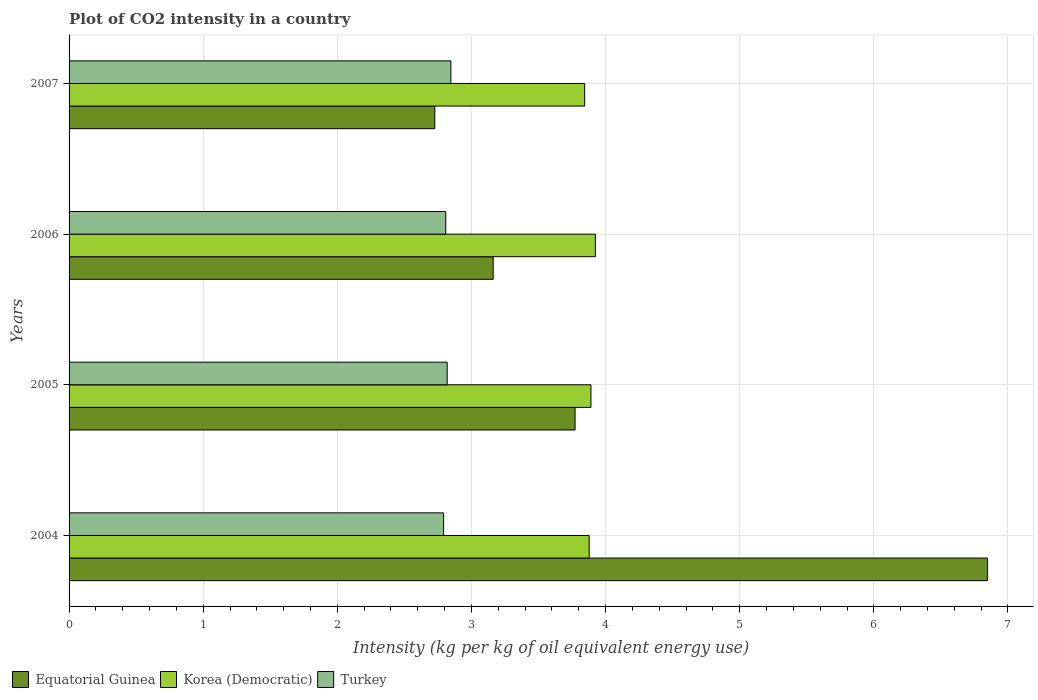How many groups of bars are there?
Offer a terse response. 4. Are the number of bars per tick equal to the number of legend labels?
Your response must be concise. Yes. How many bars are there on the 3rd tick from the top?
Your answer should be very brief. 3. What is the label of the 3rd group of bars from the top?
Your response must be concise. 2005. In how many cases, is the number of bars for a given year not equal to the number of legend labels?
Your response must be concise. 0. What is the CO2 intensity in in Equatorial Guinea in 2007?
Your answer should be compact. 2.73. Across all years, what is the maximum CO2 intensity in in Korea (Democratic)?
Offer a terse response. 3.92. Across all years, what is the minimum CO2 intensity in in Equatorial Guinea?
Provide a succinct answer. 2.73. What is the total CO2 intensity in in Korea (Democratic) in the graph?
Ensure brevity in your answer.  15.54. What is the difference between the CO2 intensity in in Turkey in 2006 and that in 2007?
Your answer should be compact. -0.04. What is the difference between the CO2 intensity in in Korea (Democratic) in 2004 and the CO2 intensity in in Equatorial Guinea in 2007?
Offer a very short reply. 1.15. What is the average CO2 intensity in in Equatorial Guinea per year?
Make the answer very short. 4.13. In the year 2007, what is the difference between the CO2 intensity in in Korea (Democratic) and CO2 intensity in in Turkey?
Offer a terse response. 1. In how many years, is the CO2 intensity in in Korea (Democratic) greater than 6.4 kg?
Your answer should be very brief. 0. What is the ratio of the CO2 intensity in in Korea (Democratic) in 2004 to that in 2007?
Keep it short and to the point. 1.01. Is the CO2 intensity in in Korea (Democratic) in 2004 less than that in 2007?
Provide a succinct answer. No. What is the difference between the highest and the second highest CO2 intensity in in Equatorial Guinea?
Make the answer very short. 3.08. What is the difference between the highest and the lowest CO2 intensity in in Korea (Democratic)?
Your response must be concise. 0.08. What does the 2nd bar from the top in 2007 represents?
Keep it short and to the point. Korea (Democratic). Is it the case that in every year, the sum of the CO2 intensity in in Turkey and CO2 intensity in in Korea (Democratic) is greater than the CO2 intensity in in Equatorial Guinea?
Keep it short and to the point. No. How many years are there in the graph?
Your response must be concise. 4. What is the difference between two consecutive major ticks on the X-axis?
Provide a succinct answer. 1. Are the values on the major ticks of X-axis written in scientific E-notation?
Offer a terse response. No. Does the graph contain any zero values?
Make the answer very short. No. Where does the legend appear in the graph?
Offer a very short reply. Bottom left. How many legend labels are there?
Your answer should be compact. 3. What is the title of the graph?
Give a very brief answer. Plot of CO2 intensity in a country. Does "Indonesia" appear as one of the legend labels in the graph?
Provide a short and direct response. No. What is the label or title of the X-axis?
Your response must be concise. Intensity (kg per kg of oil equivalent energy use). What is the Intensity (kg per kg of oil equivalent energy use) of Equatorial Guinea in 2004?
Offer a very short reply. 6.85. What is the Intensity (kg per kg of oil equivalent energy use) of Korea (Democratic) in 2004?
Ensure brevity in your answer.  3.88. What is the Intensity (kg per kg of oil equivalent energy use) in Turkey in 2004?
Give a very brief answer. 2.79. What is the Intensity (kg per kg of oil equivalent energy use) of Equatorial Guinea in 2005?
Provide a short and direct response. 3.77. What is the Intensity (kg per kg of oil equivalent energy use) of Korea (Democratic) in 2005?
Offer a terse response. 3.89. What is the Intensity (kg per kg of oil equivalent energy use) in Turkey in 2005?
Your response must be concise. 2.82. What is the Intensity (kg per kg of oil equivalent energy use) in Equatorial Guinea in 2006?
Offer a very short reply. 3.16. What is the Intensity (kg per kg of oil equivalent energy use) in Korea (Democratic) in 2006?
Give a very brief answer. 3.92. What is the Intensity (kg per kg of oil equivalent energy use) of Turkey in 2006?
Offer a terse response. 2.81. What is the Intensity (kg per kg of oil equivalent energy use) in Equatorial Guinea in 2007?
Offer a terse response. 2.73. What is the Intensity (kg per kg of oil equivalent energy use) of Korea (Democratic) in 2007?
Make the answer very short. 3.84. What is the Intensity (kg per kg of oil equivalent energy use) of Turkey in 2007?
Provide a succinct answer. 2.85. Across all years, what is the maximum Intensity (kg per kg of oil equivalent energy use) in Equatorial Guinea?
Keep it short and to the point. 6.85. Across all years, what is the maximum Intensity (kg per kg of oil equivalent energy use) of Korea (Democratic)?
Offer a terse response. 3.92. Across all years, what is the maximum Intensity (kg per kg of oil equivalent energy use) of Turkey?
Your answer should be compact. 2.85. Across all years, what is the minimum Intensity (kg per kg of oil equivalent energy use) in Equatorial Guinea?
Provide a succinct answer. 2.73. Across all years, what is the minimum Intensity (kg per kg of oil equivalent energy use) of Korea (Democratic)?
Offer a terse response. 3.84. Across all years, what is the minimum Intensity (kg per kg of oil equivalent energy use) in Turkey?
Provide a succinct answer. 2.79. What is the total Intensity (kg per kg of oil equivalent energy use) in Equatorial Guinea in the graph?
Ensure brevity in your answer.  16.51. What is the total Intensity (kg per kg of oil equivalent energy use) of Korea (Democratic) in the graph?
Ensure brevity in your answer.  15.54. What is the total Intensity (kg per kg of oil equivalent energy use) of Turkey in the graph?
Provide a short and direct response. 11.27. What is the difference between the Intensity (kg per kg of oil equivalent energy use) of Equatorial Guinea in 2004 and that in 2005?
Keep it short and to the point. 3.08. What is the difference between the Intensity (kg per kg of oil equivalent energy use) in Korea (Democratic) in 2004 and that in 2005?
Your answer should be compact. -0.01. What is the difference between the Intensity (kg per kg of oil equivalent energy use) in Turkey in 2004 and that in 2005?
Keep it short and to the point. -0.03. What is the difference between the Intensity (kg per kg of oil equivalent energy use) in Equatorial Guinea in 2004 and that in 2006?
Give a very brief answer. 3.69. What is the difference between the Intensity (kg per kg of oil equivalent energy use) in Korea (Democratic) in 2004 and that in 2006?
Make the answer very short. -0.05. What is the difference between the Intensity (kg per kg of oil equivalent energy use) of Turkey in 2004 and that in 2006?
Offer a terse response. -0.02. What is the difference between the Intensity (kg per kg of oil equivalent energy use) in Equatorial Guinea in 2004 and that in 2007?
Your answer should be compact. 4.12. What is the difference between the Intensity (kg per kg of oil equivalent energy use) of Korea (Democratic) in 2004 and that in 2007?
Provide a succinct answer. 0.03. What is the difference between the Intensity (kg per kg of oil equivalent energy use) of Turkey in 2004 and that in 2007?
Provide a short and direct response. -0.05. What is the difference between the Intensity (kg per kg of oil equivalent energy use) in Equatorial Guinea in 2005 and that in 2006?
Your answer should be compact. 0.61. What is the difference between the Intensity (kg per kg of oil equivalent energy use) of Korea (Democratic) in 2005 and that in 2006?
Offer a very short reply. -0.03. What is the difference between the Intensity (kg per kg of oil equivalent energy use) of Turkey in 2005 and that in 2006?
Keep it short and to the point. 0.01. What is the difference between the Intensity (kg per kg of oil equivalent energy use) of Equatorial Guinea in 2005 and that in 2007?
Your answer should be compact. 1.05. What is the difference between the Intensity (kg per kg of oil equivalent energy use) in Korea (Democratic) in 2005 and that in 2007?
Your answer should be very brief. 0.05. What is the difference between the Intensity (kg per kg of oil equivalent energy use) in Turkey in 2005 and that in 2007?
Provide a succinct answer. -0.03. What is the difference between the Intensity (kg per kg of oil equivalent energy use) of Equatorial Guinea in 2006 and that in 2007?
Ensure brevity in your answer.  0.44. What is the difference between the Intensity (kg per kg of oil equivalent energy use) in Korea (Democratic) in 2006 and that in 2007?
Your response must be concise. 0.08. What is the difference between the Intensity (kg per kg of oil equivalent energy use) in Turkey in 2006 and that in 2007?
Your response must be concise. -0.04. What is the difference between the Intensity (kg per kg of oil equivalent energy use) of Equatorial Guinea in 2004 and the Intensity (kg per kg of oil equivalent energy use) of Korea (Democratic) in 2005?
Make the answer very short. 2.96. What is the difference between the Intensity (kg per kg of oil equivalent energy use) in Equatorial Guinea in 2004 and the Intensity (kg per kg of oil equivalent energy use) in Turkey in 2005?
Keep it short and to the point. 4.03. What is the difference between the Intensity (kg per kg of oil equivalent energy use) of Korea (Democratic) in 2004 and the Intensity (kg per kg of oil equivalent energy use) of Turkey in 2005?
Your response must be concise. 1.06. What is the difference between the Intensity (kg per kg of oil equivalent energy use) of Equatorial Guinea in 2004 and the Intensity (kg per kg of oil equivalent energy use) of Korea (Democratic) in 2006?
Ensure brevity in your answer.  2.92. What is the difference between the Intensity (kg per kg of oil equivalent energy use) in Equatorial Guinea in 2004 and the Intensity (kg per kg of oil equivalent energy use) in Turkey in 2006?
Ensure brevity in your answer.  4.04. What is the difference between the Intensity (kg per kg of oil equivalent energy use) of Korea (Democratic) in 2004 and the Intensity (kg per kg of oil equivalent energy use) of Turkey in 2006?
Offer a very short reply. 1.07. What is the difference between the Intensity (kg per kg of oil equivalent energy use) of Equatorial Guinea in 2004 and the Intensity (kg per kg of oil equivalent energy use) of Korea (Democratic) in 2007?
Your answer should be very brief. 3. What is the difference between the Intensity (kg per kg of oil equivalent energy use) in Equatorial Guinea in 2004 and the Intensity (kg per kg of oil equivalent energy use) in Turkey in 2007?
Offer a terse response. 4. What is the difference between the Intensity (kg per kg of oil equivalent energy use) in Korea (Democratic) in 2004 and the Intensity (kg per kg of oil equivalent energy use) in Turkey in 2007?
Your response must be concise. 1.03. What is the difference between the Intensity (kg per kg of oil equivalent energy use) of Equatorial Guinea in 2005 and the Intensity (kg per kg of oil equivalent energy use) of Korea (Democratic) in 2006?
Your response must be concise. -0.15. What is the difference between the Intensity (kg per kg of oil equivalent energy use) of Equatorial Guinea in 2005 and the Intensity (kg per kg of oil equivalent energy use) of Turkey in 2006?
Ensure brevity in your answer.  0.96. What is the difference between the Intensity (kg per kg of oil equivalent energy use) of Korea (Democratic) in 2005 and the Intensity (kg per kg of oil equivalent energy use) of Turkey in 2006?
Keep it short and to the point. 1.08. What is the difference between the Intensity (kg per kg of oil equivalent energy use) of Equatorial Guinea in 2005 and the Intensity (kg per kg of oil equivalent energy use) of Korea (Democratic) in 2007?
Make the answer very short. -0.07. What is the difference between the Intensity (kg per kg of oil equivalent energy use) of Equatorial Guinea in 2005 and the Intensity (kg per kg of oil equivalent energy use) of Turkey in 2007?
Your answer should be very brief. 0.93. What is the difference between the Intensity (kg per kg of oil equivalent energy use) of Korea (Democratic) in 2005 and the Intensity (kg per kg of oil equivalent energy use) of Turkey in 2007?
Your answer should be very brief. 1.04. What is the difference between the Intensity (kg per kg of oil equivalent energy use) in Equatorial Guinea in 2006 and the Intensity (kg per kg of oil equivalent energy use) in Korea (Democratic) in 2007?
Make the answer very short. -0.68. What is the difference between the Intensity (kg per kg of oil equivalent energy use) in Equatorial Guinea in 2006 and the Intensity (kg per kg of oil equivalent energy use) in Turkey in 2007?
Offer a very short reply. 0.32. What is the difference between the Intensity (kg per kg of oil equivalent energy use) in Korea (Democratic) in 2006 and the Intensity (kg per kg of oil equivalent energy use) in Turkey in 2007?
Your response must be concise. 1.08. What is the average Intensity (kg per kg of oil equivalent energy use) in Equatorial Guinea per year?
Your answer should be compact. 4.13. What is the average Intensity (kg per kg of oil equivalent energy use) in Korea (Democratic) per year?
Your answer should be very brief. 3.88. What is the average Intensity (kg per kg of oil equivalent energy use) in Turkey per year?
Offer a very short reply. 2.82. In the year 2004, what is the difference between the Intensity (kg per kg of oil equivalent energy use) in Equatorial Guinea and Intensity (kg per kg of oil equivalent energy use) in Korea (Democratic)?
Offer a terse response. 2.97. In the year 2004, what is the difference between the Intensity (kg per kg of oil equivalent energy use) in Equatorial Guinea and Intensity (kg per kg of oil equivalent energy use) in Turkey?
Provide a short and direct response. 4.06. In the year 2004, what is the difference between the Intensity (kg per kg of oil equivalent energy use) in Korea (Democratic) and Intensity (kg per kg of oil equivalent energy use) in Turkey?
Provide a succinct answer. 1.09. In the year 2005, what is the difference between the Intensity (kg per kg of oil equivalent energy use) of Equatorial Guinea and Intensity (kg per kg of oil equivalent energy use) of Korea (Democratic)?
Keep it short and to the point. -0.12. In the year 2005, what is the difference between the Intensity (kg per kg of oil equivalent energy use) in Equatorial Guinea and Intensity (kg per kg of oil equivalent energy use) in Turkey?
Your answer should be very brief. 0.95. In the year 2005, what is the difference between the Intensity (kg per kg of oil equivalent energy use) in Korea (Democratic) and Intensity (kg per kg of oil equivalent energy use) in Turkey?
Ensure brevity in your answer.  1.07. In the year 2006, what is the difference between the Intensity (kg per kg of oil equivalent energy use) of Equatorial Guinea and Intensity (kg per kg of oil equivalent energy use) of Korea (Democratic)?
Make the answer very short. -0.76. In the year 2006, what is the difference between the Intensity (kg per kg of oil equivalent energy use) in Equatorial Guinea and Intensity (kg per kg of oil equivalent energy use) in Turkey?
Give a very brief answer. 0.35. In the year 2006, what is the difference between the Intensity (kg per kg of oil equivalent energy use) of Korea (Democratic) and Intensity (kg per kg of oil equivalent energy use) of Turkey?
Ensure brevity in your answer.  1.12. In the year 2007, what is the difference between the Intensity (kg per kg of oil equivalent energy use) of Equatorial Guinea and Intensity (kg per kg of oil equivalent energy use) of Korea (Democratic)?
Give a very brief answer. -1.12. In the year 2007, what is the difference between the Intensity (kg per kg of oil equivalent energy use) in Equatorial Guinea and Intensity (kg per kg of oil equivalent energy use) in Turkey?
Your answer should be very brief. -0.12. What is the ratio of the Intensity (kg per kg of oil equivalent energy use) in Equatorial Guinea in 2004 to that in 2005?
Keep it short and to the point. 1.82. What is the ratio of the Intensity (kg per kg of oil equivalent energy use) of Turkey in 2004 to that in 2005?
Provide a succinct answer. 0.99. What is the ratio of the Intensity (kg per kg of oil equivalent energy use) in Equatorial Guinea in 2004 to that in 2006?
Give a very brief answer. 2.17. What is the ratio of the Intensity (kg per kg of oil equivalent energy use) in Korea (Democratic) in 2004 to that in 2006?
Provide a short and direct response. 0.99. What is the ratio of the Intensity (kg per kg of oil equivalent energy use) in Equatorial Guinea in 2004 to that in 2007?
Keep it short and to the point. 2.51. What is the ratio of the Intensity (kg per kg of oil equivalent energy use) of Korea (Democratic) in 2004 to that in 2007?
Provide a short and direct response. 1.01. What is the ratio of the Intensity (kg per kg of oil equivalent energy use) in Turkey in 2004 to that in 2007?
Provide a succinct answer. 0.98. What is the ratio of the Intensity (kg per kg of oil equivalent energy use) of Equatorial Guinea in 2005 to that in 2006?
Your answer should be compact. 1.19. What is the ratio of the Intensity (kg per kg of oil equivalent energy use) of Turkey in 2005 to that in 2006?
Offer a terse response. 1. What is the ratio of the Intensity (kg per kg of oil equivalent energy use) of Equatorial Guinea in 2005 to that in 2007?
Provide a short and direct response. 1.38. What is the ratio of the Intensity (kg per kg of oil equivalent energy use) in Korea (Democratic) in 2005 to that in 2007?
Keep it short and to the point. 1.01. What is the ratio of the Intensity (kg per kg of oil equivalent energy use) of Turkey in 2005 to that in 2007?
Your response must be concise. 0.99. What is the ratio of the Intensity (kg per kg of oil equivalent energy use) in Equatorial Guinea in 2006 to that in 2007?
Provide a short and direct response. 1.16. What is the ratio of the Intensity (kg per kg of oil equivalent energy use) of Korea (Democratic) in 2006 to that in 2007?
Keep it short and to the point. 1.02. What is the ratio of the Intensity (kg per kg of oil equivalent energy use) in Turkey in 2006 to that in 2007?
Offer a very short reply. 0.99. What is the difference between the highest and the second highest Intensity (kg per kg of oil equivalent energy use) in Equatorial Guinea?
Your answer should be compact. 3.08. What is the difference between the highest and the second highest Intensity (kg per kg of oil equivalent energy use) of Korea (Democratic)?
Make the answer very short. 0.03. What is the difference between the highest and the second highest Intensity (kg per kg of oil equivalent energy use) in Turkey?
Offer a terse response. 0.03. What is the difference between the highest and the lowest Intensity (kg per kg of oil equivalent energy use) in Equatorial Guinea?
Provide a succinct answer. 4.12. What is the difference between the highest and the lowest Intensity (kg per kg of oil equivalent energy use) of Korea (Democratic)?
Offer a very short reply. 0.08. What is the difference between the highest and the lowest Intensity (kg per kg of oil equivalent energy use) in Turkey?
Offer a very short reply. 0.05. 